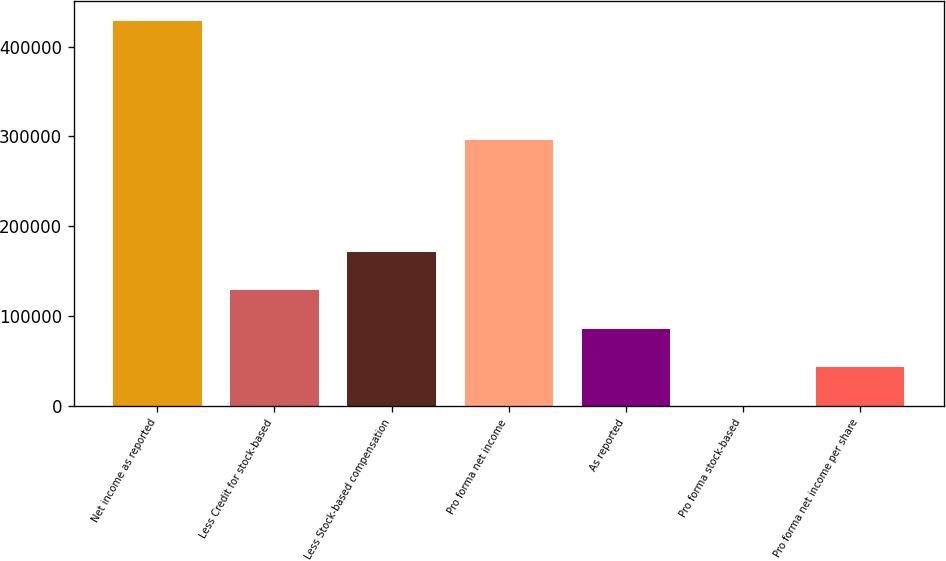Convert chart. <chart><loc_0><loc_0><loc_500><loc_500><bar_chart><fcel>Net income as reported<fcel>Less Credit for stock-based<fcel>Less Stock-based compensation<fcel>Pro forma net income<fcel>As reported<fcel>Pro forma stock-based<fcel>Pro forma net income per share<nl><fcel>428978<fcel>128694<fcel>171592<fcel>295590<fcel>85796<fcel>0.52<fcel>42898.3<nl></chart> 